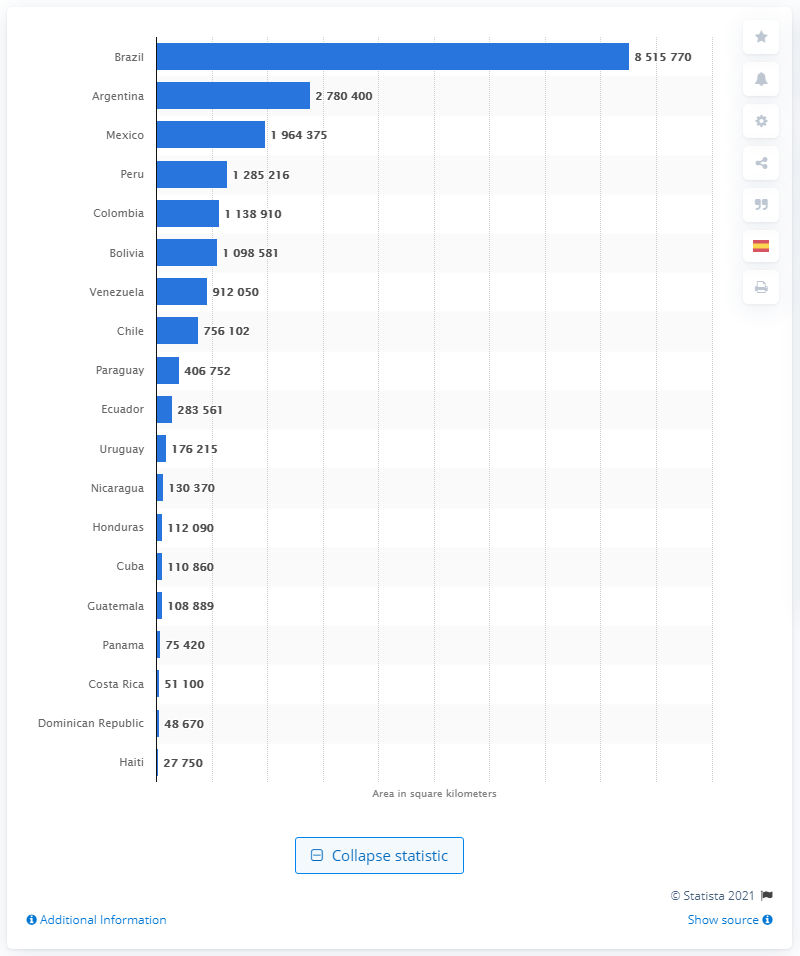What is the largest country in Latin America? Brazil is the largest country in Latin America, covering an area of approximately 8,515,770 square kilometers as shown in the bar graph, which makes it significantly larger than the next largest country, Argentina, with an area of approximately 2,780,400 square kilometers. 